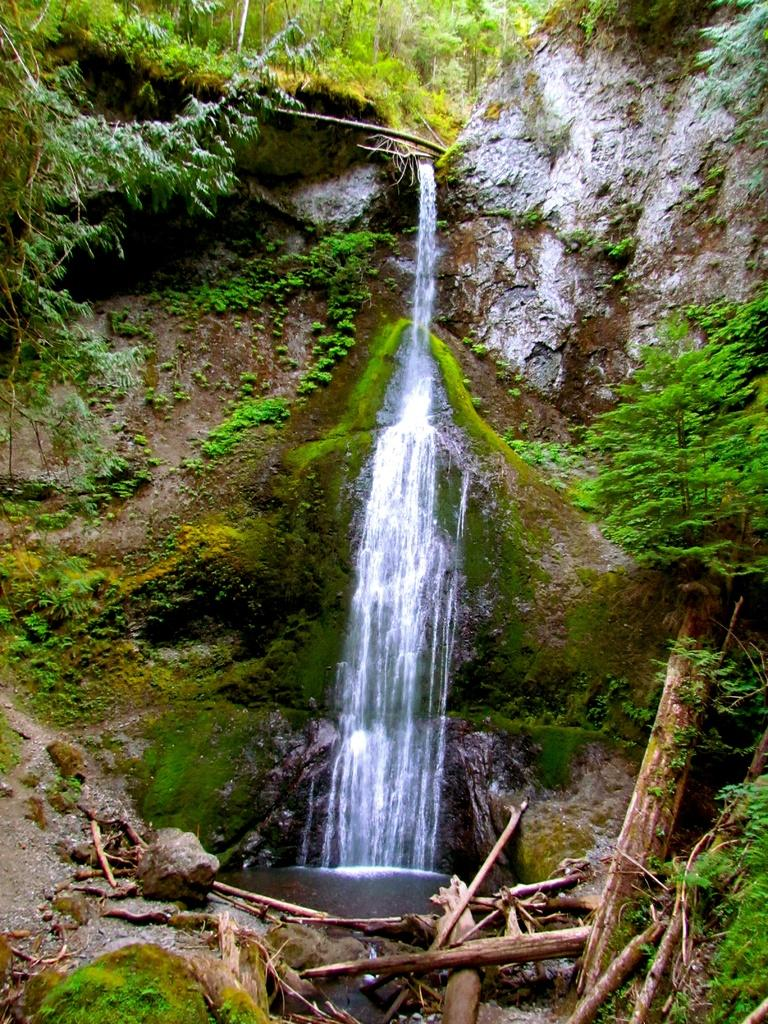What is the main feature in the middle of the image? There is a waterfall in the middle of the image. What type of vegetation can be seen on the right side of the image? There are plants on the right side of the image. What material is present at the bottom of the image? Wood is present at the bottom of the image. What type of silk is draped over the waterfall in the image? There is no silk present in the image; it features a waterfall, plants, and wood. What kind of toys can be seen in the hands of the people in the image? There are no people or toys present in the image. 